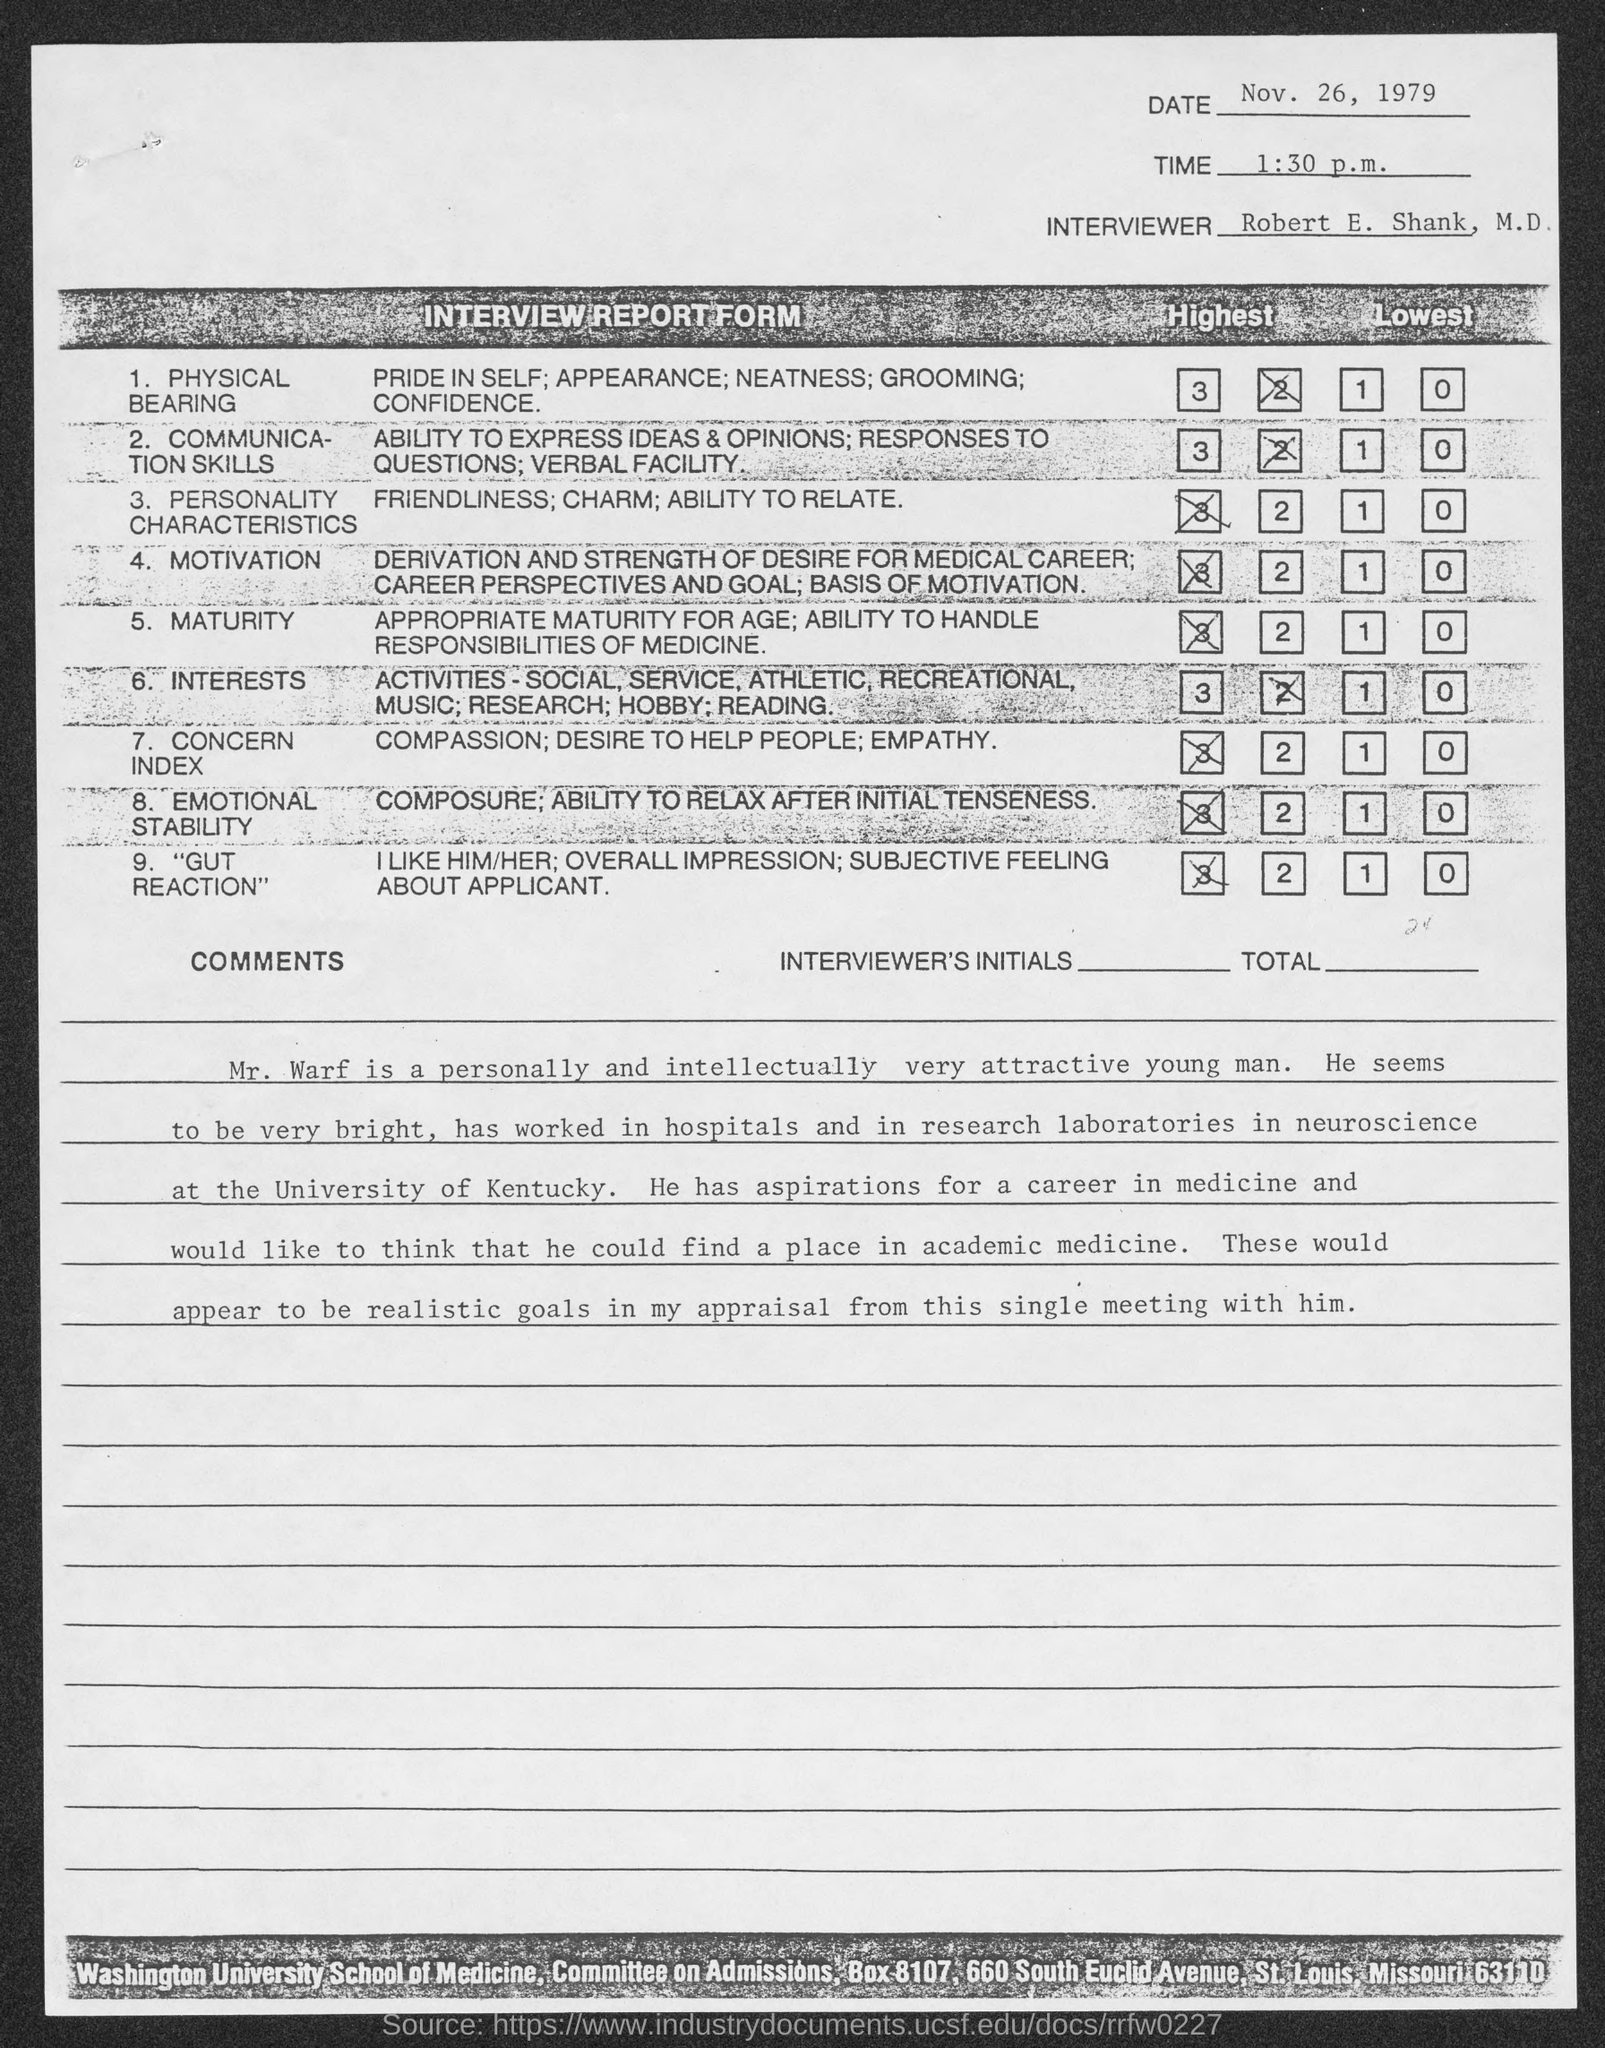In which university hospitals and laboratories  that Mr.Warf worked ?
Keep it short and to the point. University of Kentucky. 